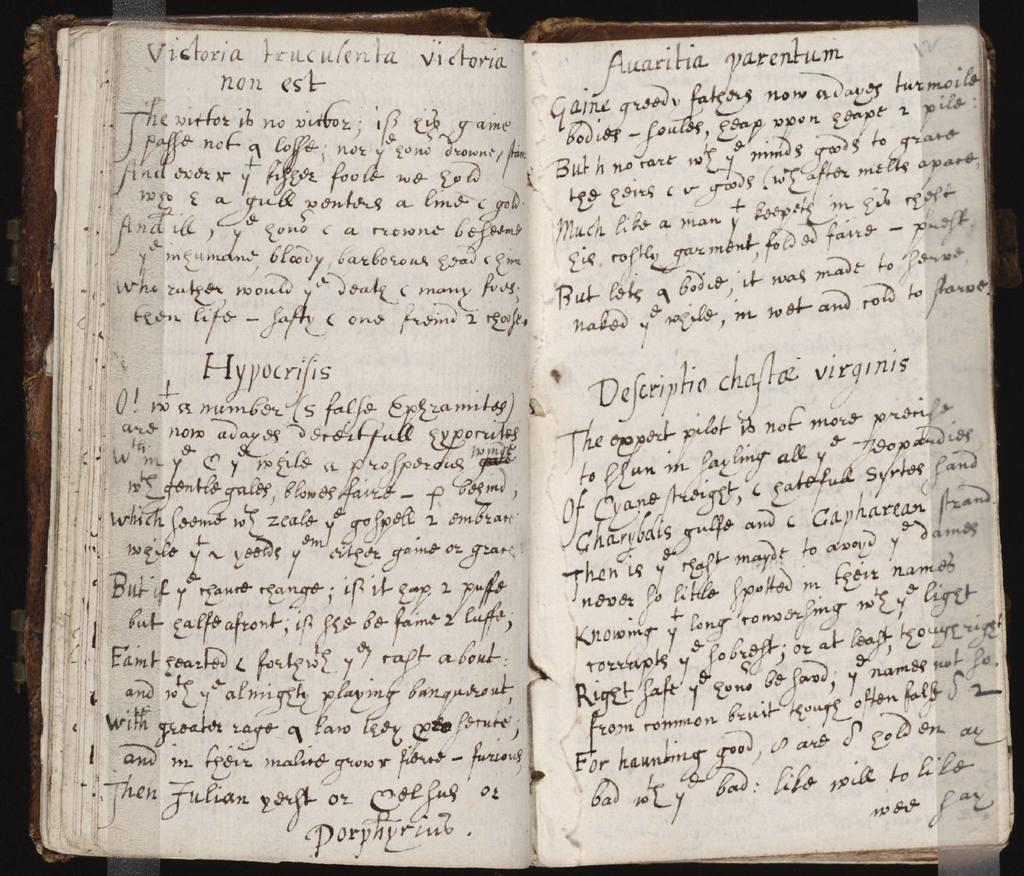<image>
Render a clear and concise summary of the photo. A handwritten notebook has the name Victoria on the top line of the left-hand page. 